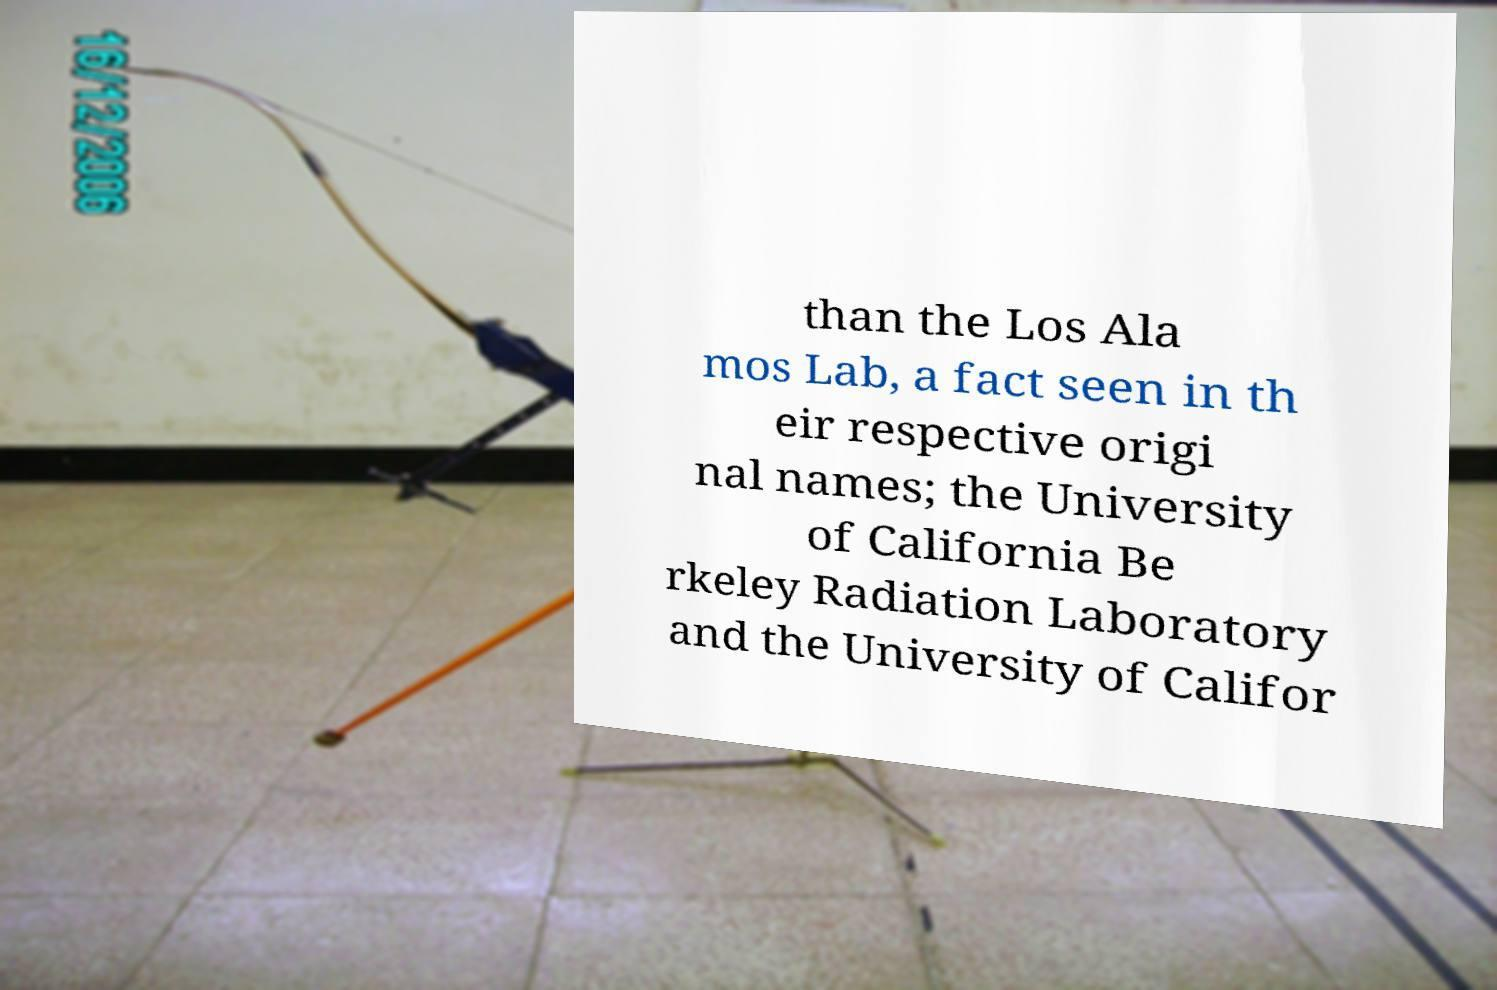There's text embedded in this image that I need extracted. Can you transcribe it verbatim? than the Los Ala mos Lab, a fact seen in th eir respective origi nal names; the University of California Be rkeley Radiation Laboratory and the University of Califor 